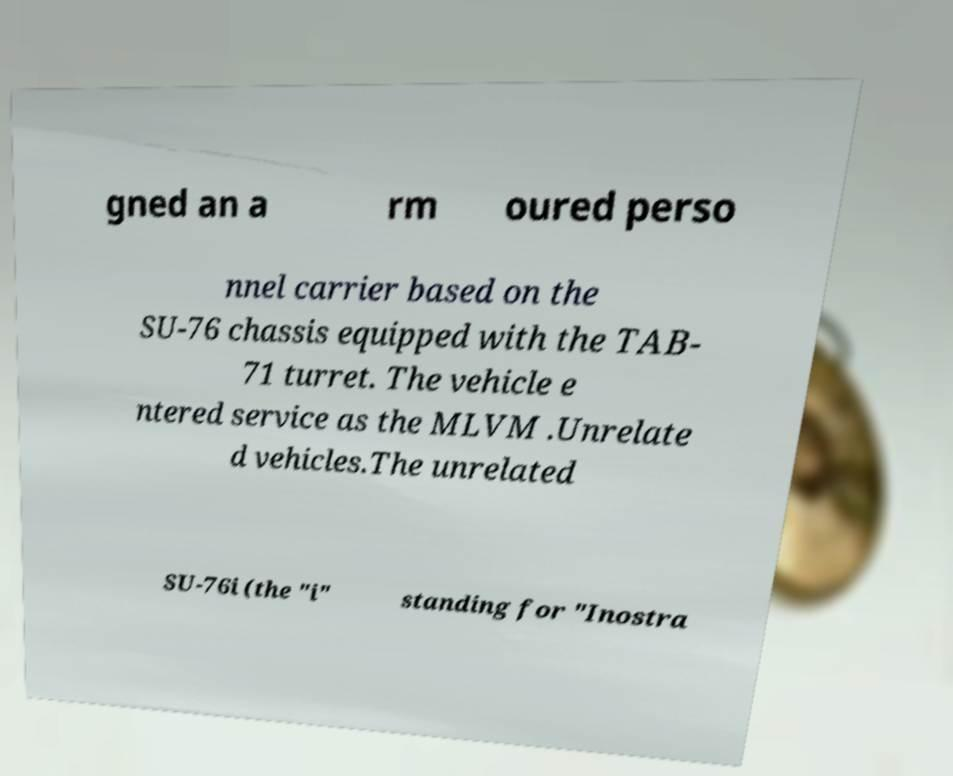There's text embedded in this image that I need extracted. Can you transcribe it verbatim? gned an a rm oured perso nnel carrier based on the SU-76 chassis equipped with the TAB- 71 turret. The vehicle e ntered service as the MLVM .Unrelate d vehicles.The unrelated SU-76i (the "i" standing for "Inostra 